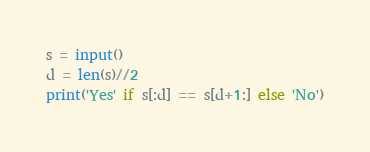Convert code to text. <code><loc_0><loc_0><loc_500><loc_500><_Python_>s = input()
d = len(s)//2
print('Yes' if s[:d] == s[d+1:] else 'No')</code> 